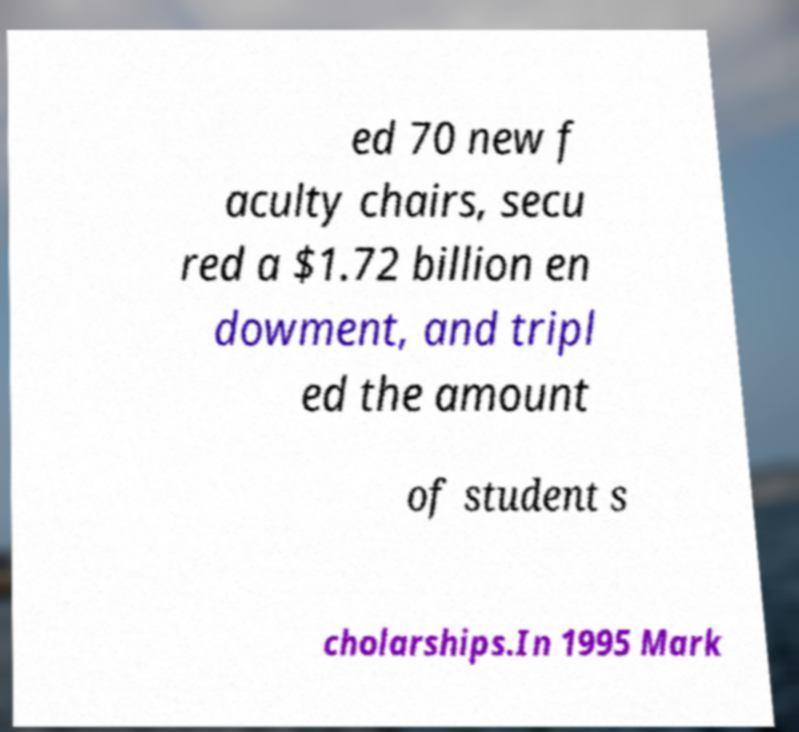Please read and relay the text visible in this image. What does it say? ed 70 new f aculty chairs, secu red a $1.72 billion en dowment, and tripl ed the amount of student s cholarships.In 1995 Mark 